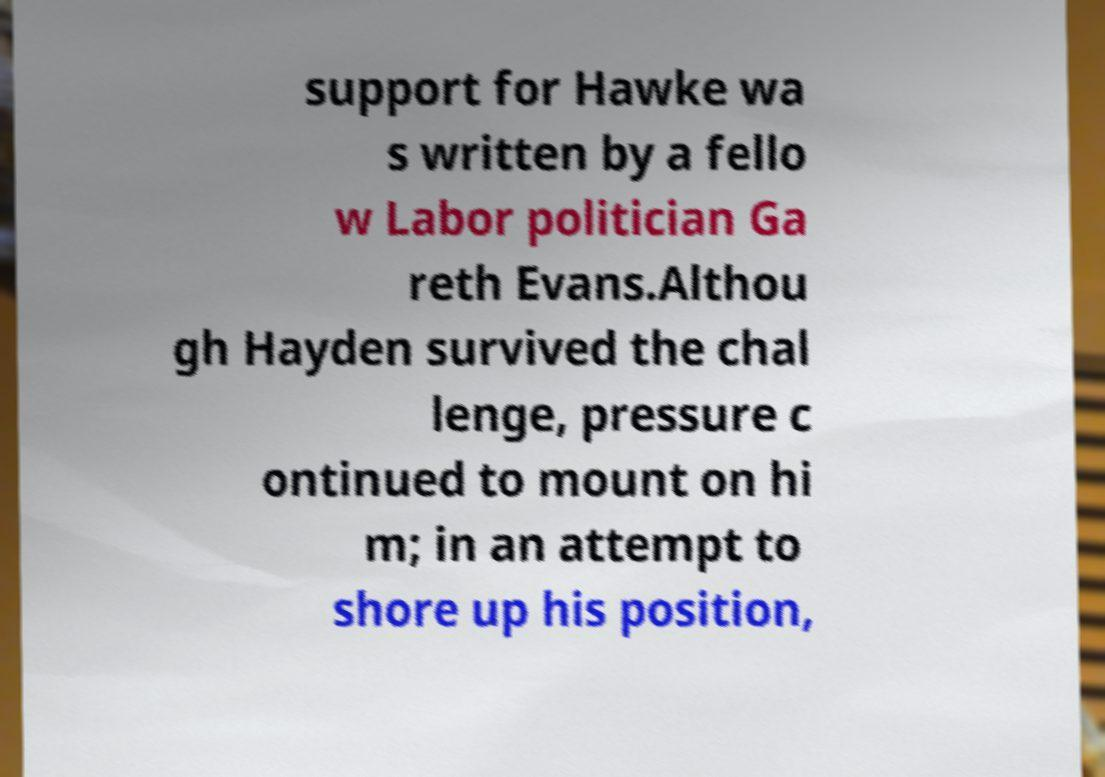What messages or text are displayed in this image? I need them in a readable, typed format. support for Hawke wa s written by a fello w Labor politician Ga reth Evans.Althou gh Hayden survived the chal lenge, pressure c ontinued to mount on hi m; in an attempt to shore up his position, 